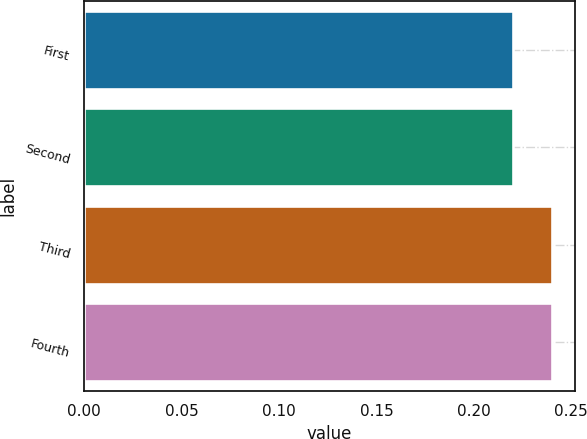Convert chart to OTSL. <chart><loc_0><loc_0><loc_500><loc_500><bar_chart><fcel>First<fcel>Second<fcel>Third<fcel>Fourth<nl><fcel>0.22<fcel>0.22<fcel>0.24<fcel>0.24<nl></chart> 